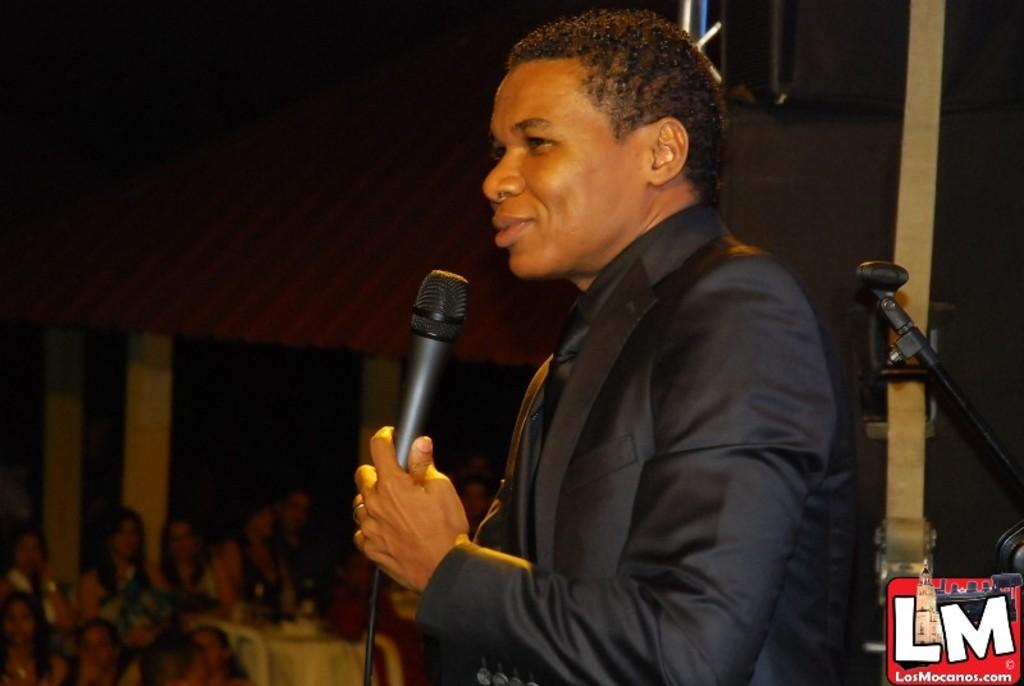What is the overall tone of the image based on the background? The background of the image is dark. Can you describe the people in the image? There are people in the image. What is the man holding in his hand? The man is holding a microphone in his hand. What is the man's expression in the image? The man is smiling. How many deer can be seen in the image? There are no deer present in the image. What type of division is taking place in the image? There is no division or separation of any kind depicted in the image. 